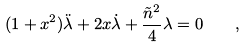Convert formula to latex. <formula><loc_0><loc_0><loc_500><loc_500>( 1 + x ^ { 2 } ) \ddot { \lambda } + 2 x \dot { \lambda } + \frac { \tilde { n } ^ { 2 } } { 4 } \lambda = 0 \quad ,</formula> 